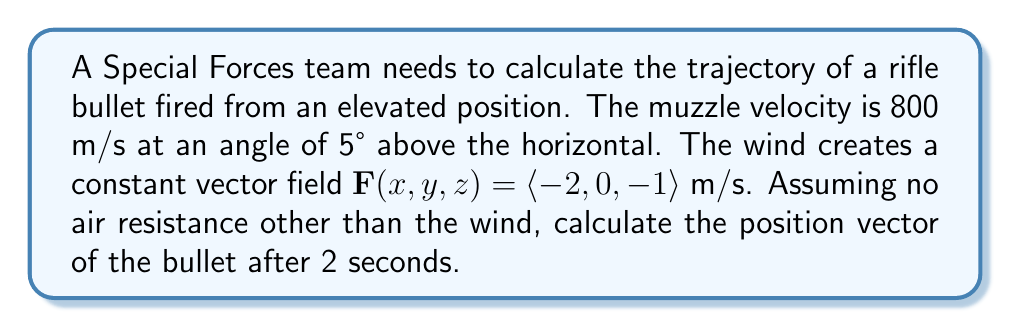Solve this math problem. Let's approach this step-by-step:

1) First, we need to determine the initial velocity vector:
   $\mathbf{v}_0 = 800 \langle \cos(5°), 0, \sin(5°) \rangle$ m/s
   $\mathbf{v}_0 = \langle 796.76, 0, 69.76 \rangle$ m/s

2) The acceleration due to gravity is $\mathbf{g} = \langle 0, 0, -9.8 \rangle$ m/s²

3) The wind vector field $\mathbf{F}(x,y,z) = \langle -2, 0, -1 \rangle$ m/s acts as a constant acceleration:
   $\mathbf{a}_w = \langle -2, 0, -1 \rangle$ m/s²

4) The total acceleration is:
   $\mathbf{a} = \mathbf{g} + \mathbf{a}_w = \langle -2, 0, -10.8 \rangle$ m/s²

5) The position vector as a function of time is given by:
   $$\mathbf{r}(t) = \mathbf{r}_0 + \mathbf{v}_0t + \frac{1}{2}\mathbf{a}t^2$$

   Where $\mathbf{r}_0 = \langle 0, 0, 0 \rangle$ (assuming the origin is at the firing position)

6) Substituting the values and t = 2s:
   $$\mathbf{r}(2) = \langle 0, 0, 0 \rangle + \langle 796.76, 0, 69.76 \rangle(2) + \frac{1}{2}\langle -2, 0, -10.8 \rangle(2^2)$$

7) Calculating:
   $$\mathbf{r}(2) = \langle 0, 0, 0 \rangle + \langle 1593.52, 0, 139.52 \rangle + \langle -4, 0, -21.6 \rangle$$

8) Adding the vectors:
   $$\mathbf{r}(2) = \langle 1589.52, 0, 117.92 \rangle$$
Answer: $\langle 1589.52, 0, 117.92 \rangle$ m 